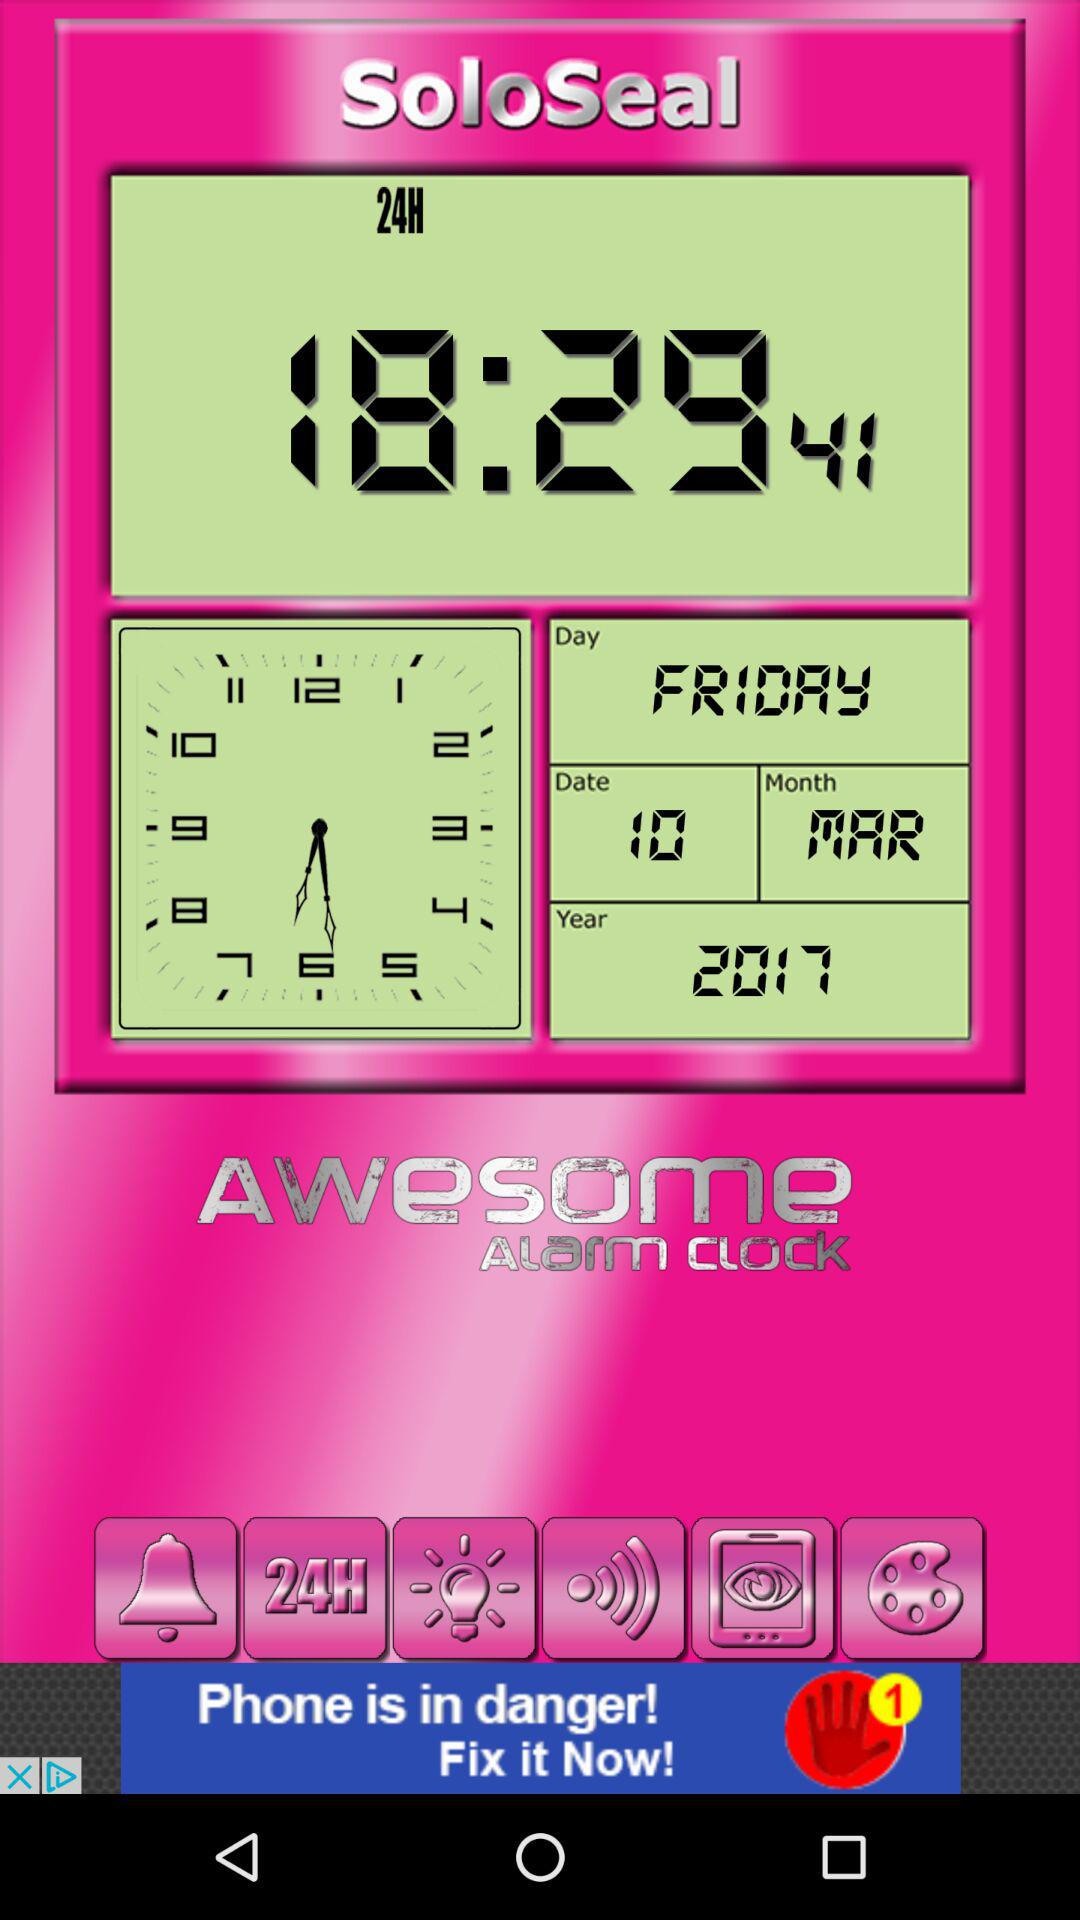What is the year? The year is 2017. 